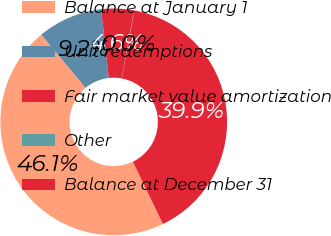Convert chart to OTSL. <chart><loc_0><loc_0><loc_500><loc_500><pie_chart><fcel>Balance at January 1<fcel>Unit redemptions<fcel>Fair market value amortization<fcel>Other<fcel>Balance at December 31<nl><fcel>46.13%<fcel>9.25%<fcel>4.64%<fcel>0.04%<fcel>39.94%<nl></chart> 